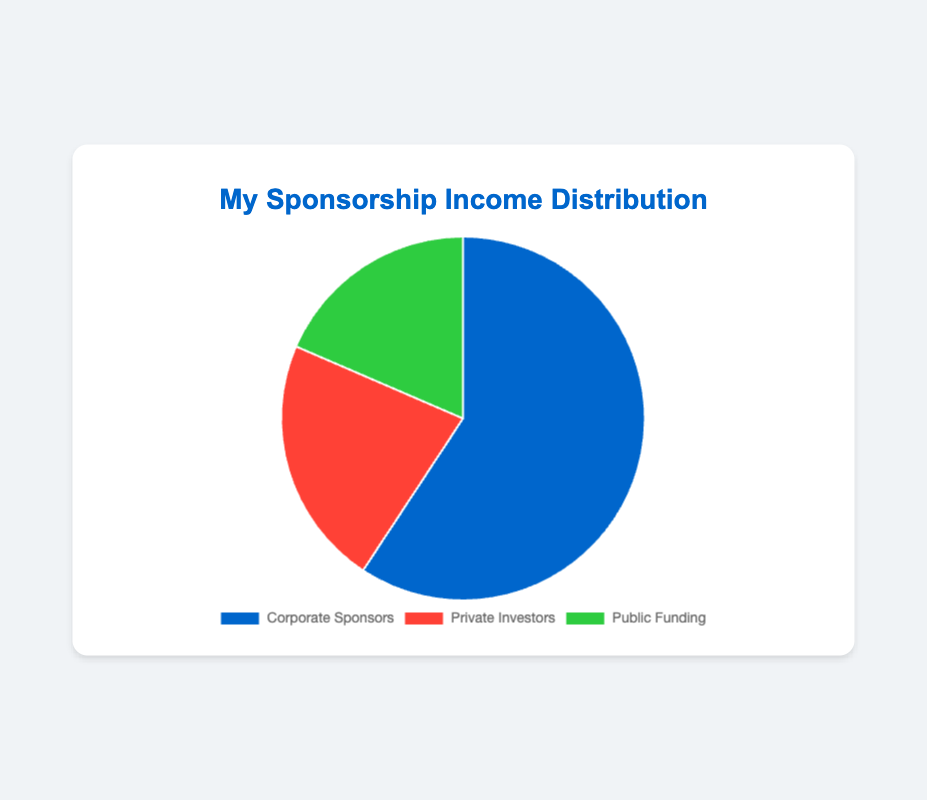What is the largest source of sponsorship income? The largest slice on the pie chart represents the entity that accounts for the biggest percentage of the total sponsorship income.
Answer: Corporate Sponsors Which sources contribute equally to the sponsorship income? By visually evaluating the segments, we find two segments of roughly equal size.
Answer: Private Investors and Public Funding How much more, in terms of percentage, does Corporate Sponsors contribute compared to Private Investors? Corporate Sponsors contribute 80%, while Private Investors contribute 30%. The difference is 80% - 30%.
Answer: 50% What is the total percentage of sponsorship income coming from Corporate Sponsors and Public Funding? Add the percentages of Corporate Sponsors (80%) and Public Funding (25%).
Answer: 105% Which source has the smallest contribution to the sponsorship income? The smallest slice on the pie chart represents the source with the least percentage.
Answer: Public Funding If you combine the contributions of Private Investors and Public Funding, would it exceed that of Corporate Sponsors? Sum the percentages of Private Investors (30%) and Public Funding (25%), then compare the sum to Corporate Sponsors (80%).
Answer: No Determine the ratio of the contributions of Corporate Sponsors to the total income from Private Investors and Public Funding combined. The total income from Private Investors and Public Funding is 30% + 25% = 55%. The ratio of Corporate Sponsors (80%) to this combined value is 80:55.
Answer: 16:11 If Corporate Sponsors were to increase their contribution by 10%, what would their new percentage distribution look like? Adding 10% to Corporate Sponsors' current 80% gives them a new percentage of 80% + 10%.
Answer: 90% What visual attribute distinguishes Corporate Sponsors from Private Investors? Corporate Sponsors are represented by a blue segment, and Private Investors are represented by a red segment in the pie chart.
Answer: Color Which sponsorship source has a segment that appears green on the pie chart? Evaluate the pie chart segments by color to find out which one is green.
Answer: Public Funding 